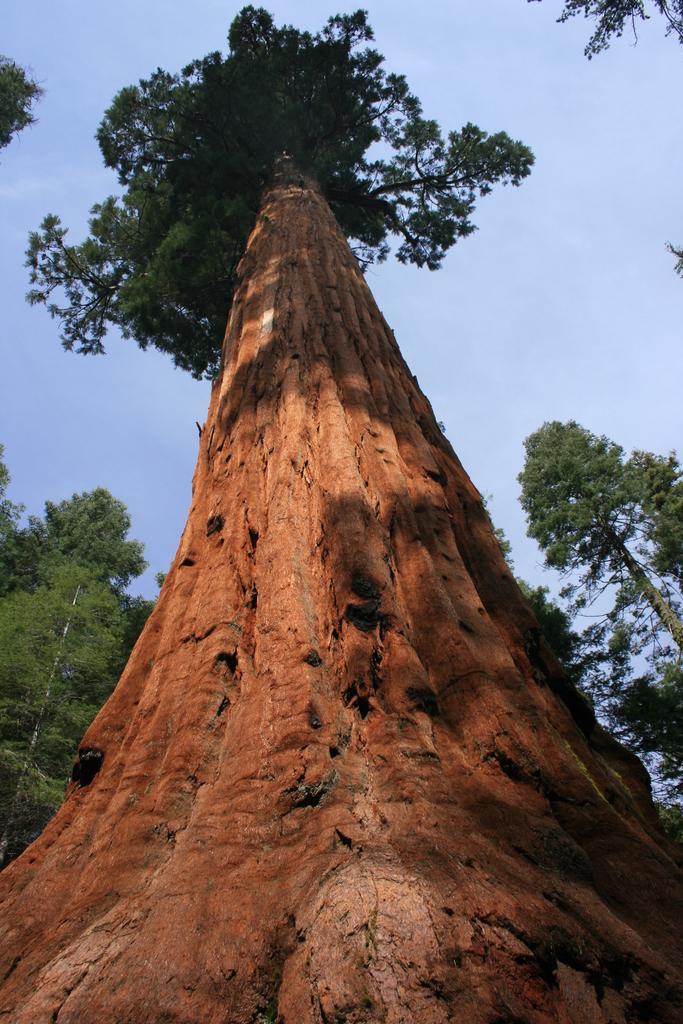Can you describe this image briefly? In this picture there are trees. At the top there is sky. 